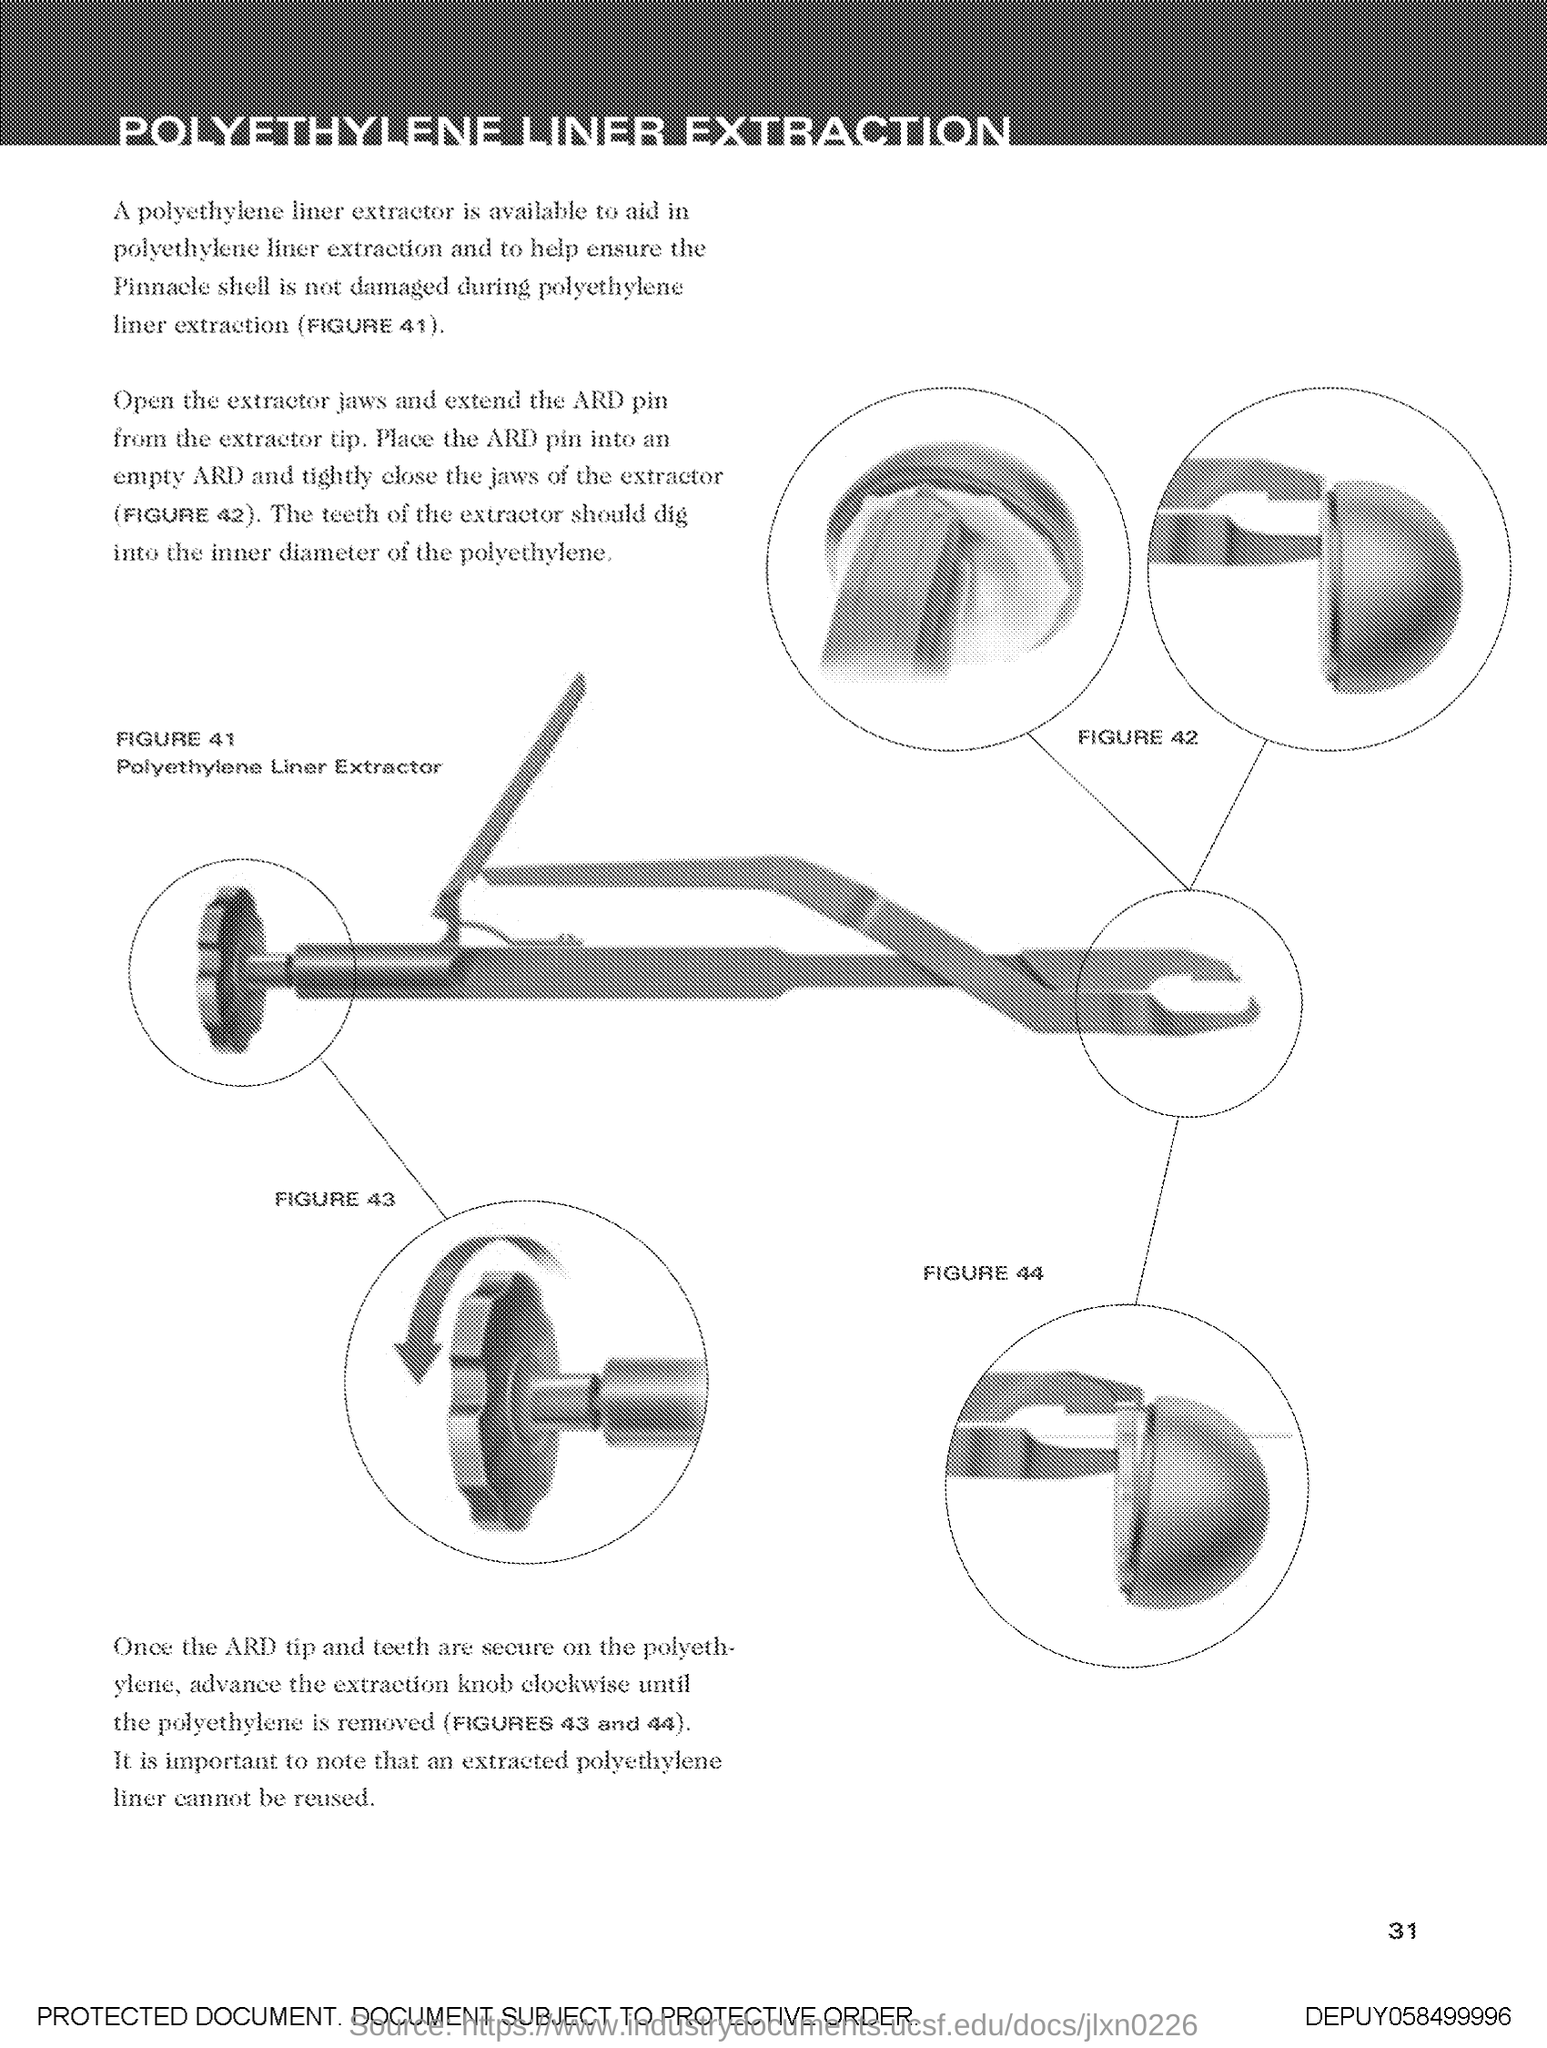Highlight a few significant elements in this photo. FIGURE 41 in this document depicts a polyethylene liner extractor. 